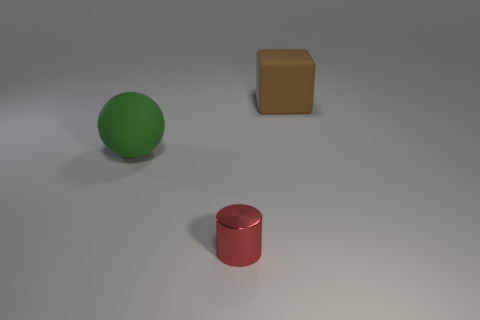Are there any other things that are the same size as the red metal thing?
Your answer should be compact. No. There is a large rubber thing that is in front of the big thing that is to the right of the tiny red object; what is its shape?
Offer a terse response. Sphere. There is a rubber object that is left of the brown rubber object; how big is it?
Keep it short and to the point. Large. Do the small thing and the ball have the same material?
Keep it short and to the point. No. What is the shape of the thing that is made of the same material as the large cube?
Offer a very short reply. Sphere. Is there any other thing of the same color as the sphere?
Keep it short and to the point. No. What color is the object that is in front of the green ball?
Keep it short and to the point. Red. What number of brown objects are the same size as the red shiny cylinder?
Make the answer very short. 0. What is the shape of the metallic thing?
Offer a very short reply. Cylinder. What is the size of the thing that is in front of the brown rubber block and behind the red metallic object?
Provide a short and direct response. Large. 